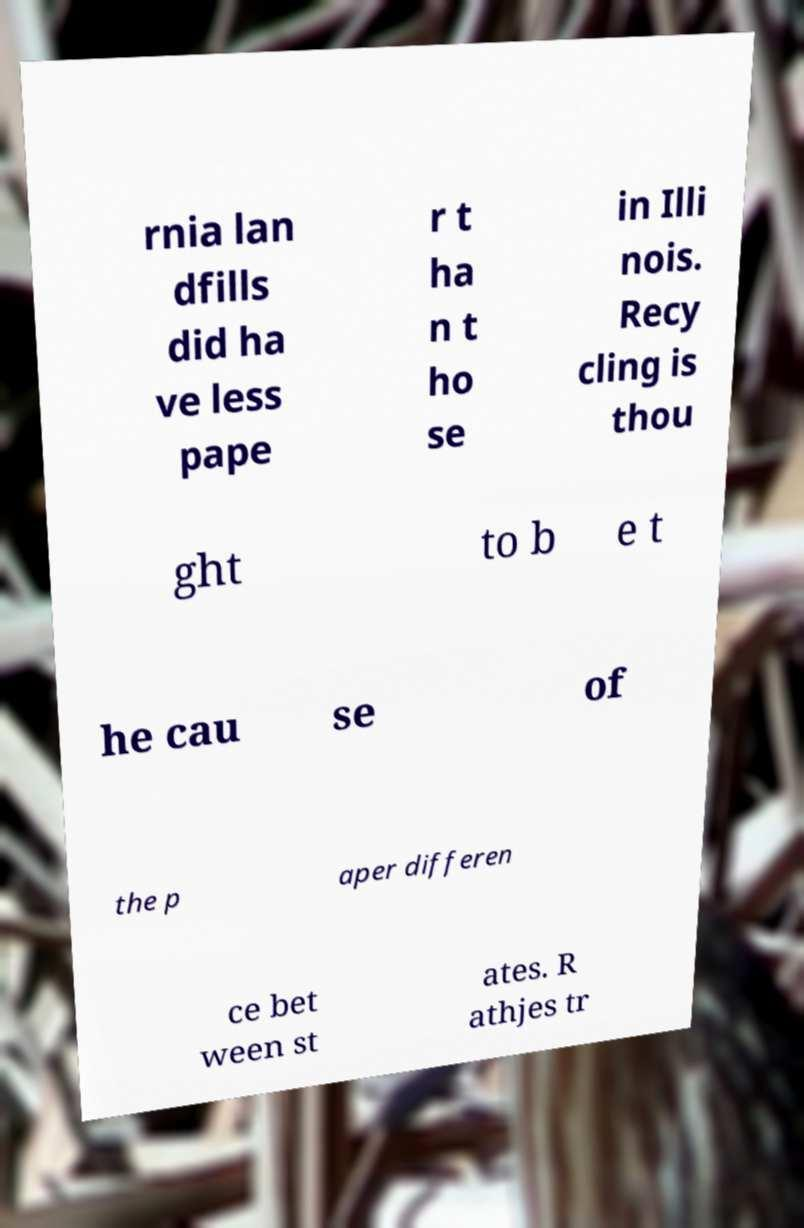Can you read and provide the text displayed in the image?This photo seems to have some interesting text. Can you extract and type it out for me? rnia lan dfills did ha ve less pape r t ha n t ho se in Illi nois. Recy cling is thou ght to b e t he cau se of the p aper differen ce bet ween st ates. R athjes tr 